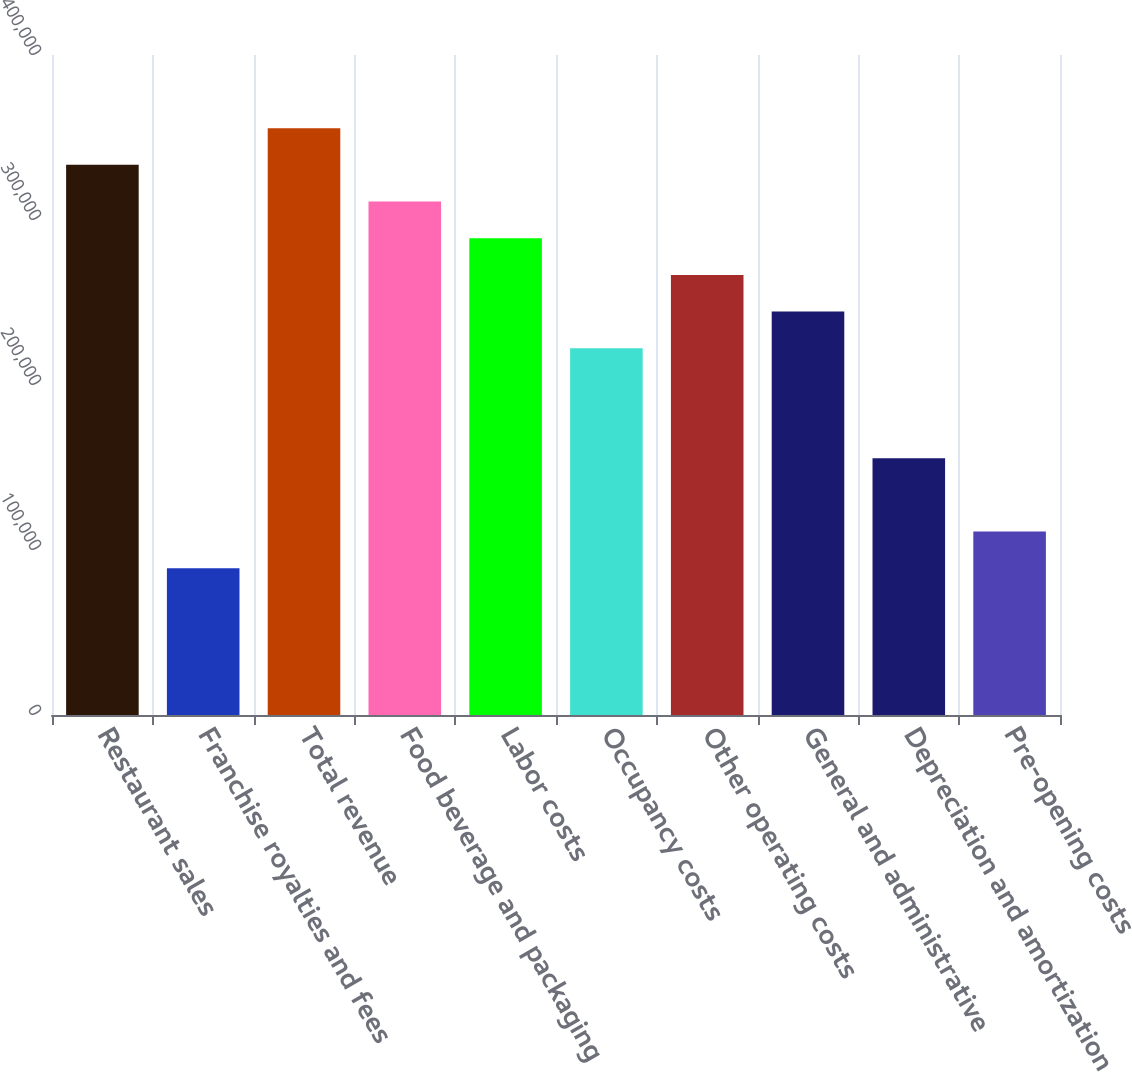Convert chart to OTSL. <chart><loc_0><loc_0><loc_500><loc_500><bar_chart><fcel>Restaurant sales<fcel>Franchise royalties and fees<fcel>Total revenue<fcel>Food beverage and packaging<fcel>Labor costs<fcel>Occupancy costs<fcel>Other operating costs<fcel>General and administrative<fcel>Depreciation and amortization<fcel>Pre-opening costs<nl><fcel>333415<fcel>88911.3<fcel>355643<fcel>311187<fcel>288960<fcel>222277<fcel>266732<fcel>244505<fcel>155594<fcel>111139<nl></chart> 